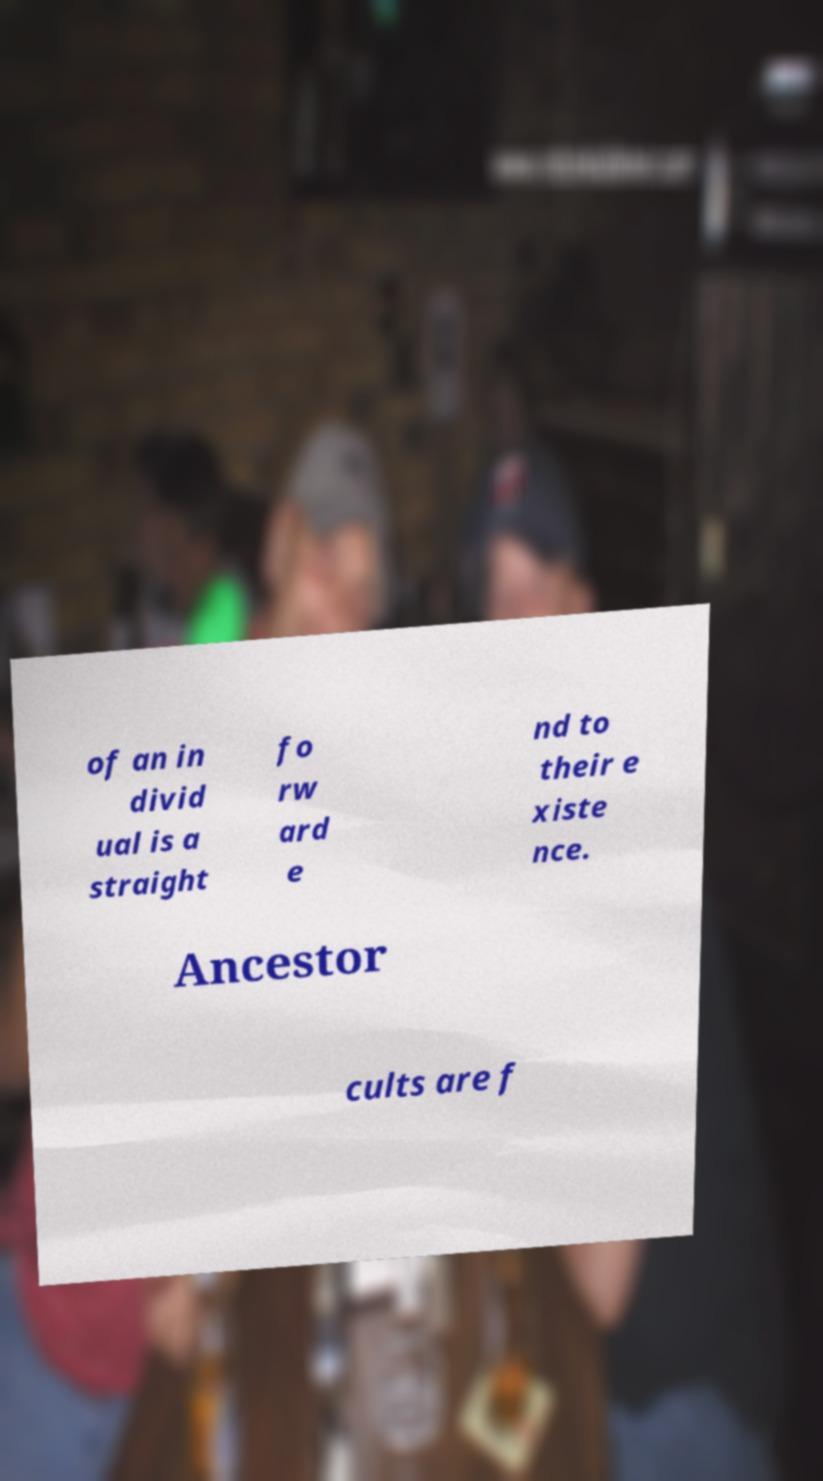Please read and relay the text visible in this image. What does it say? of an in divid ual is a straight fo rw ard e nd to their e xiste nce. Ancestor cults are f 